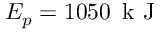<formula> <loc_0><loc_0><loc_500><loc_500>E _ { p } = 1 0 5 0 \, k J</formula> 